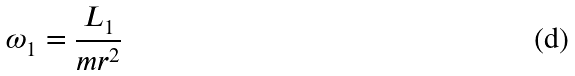Convert formula to latex. <formula><loc_0><loc_0><loc_500><loc_500>\omega _ { 1 } = \frac { L _ { 1 } } { m r ^ { 2 } }</formula> 